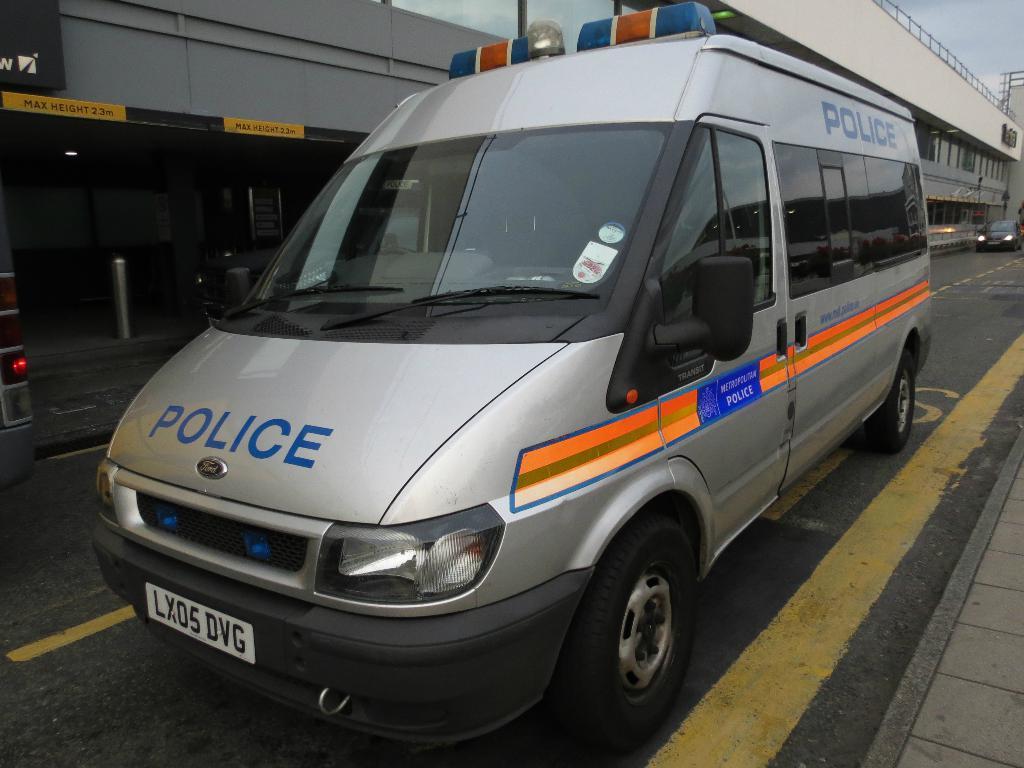What vehicle is this for?
Ensure brevity in your answer.  Police. What is the license plate number?
Your answer should be very brief. Lx05 dvg. 